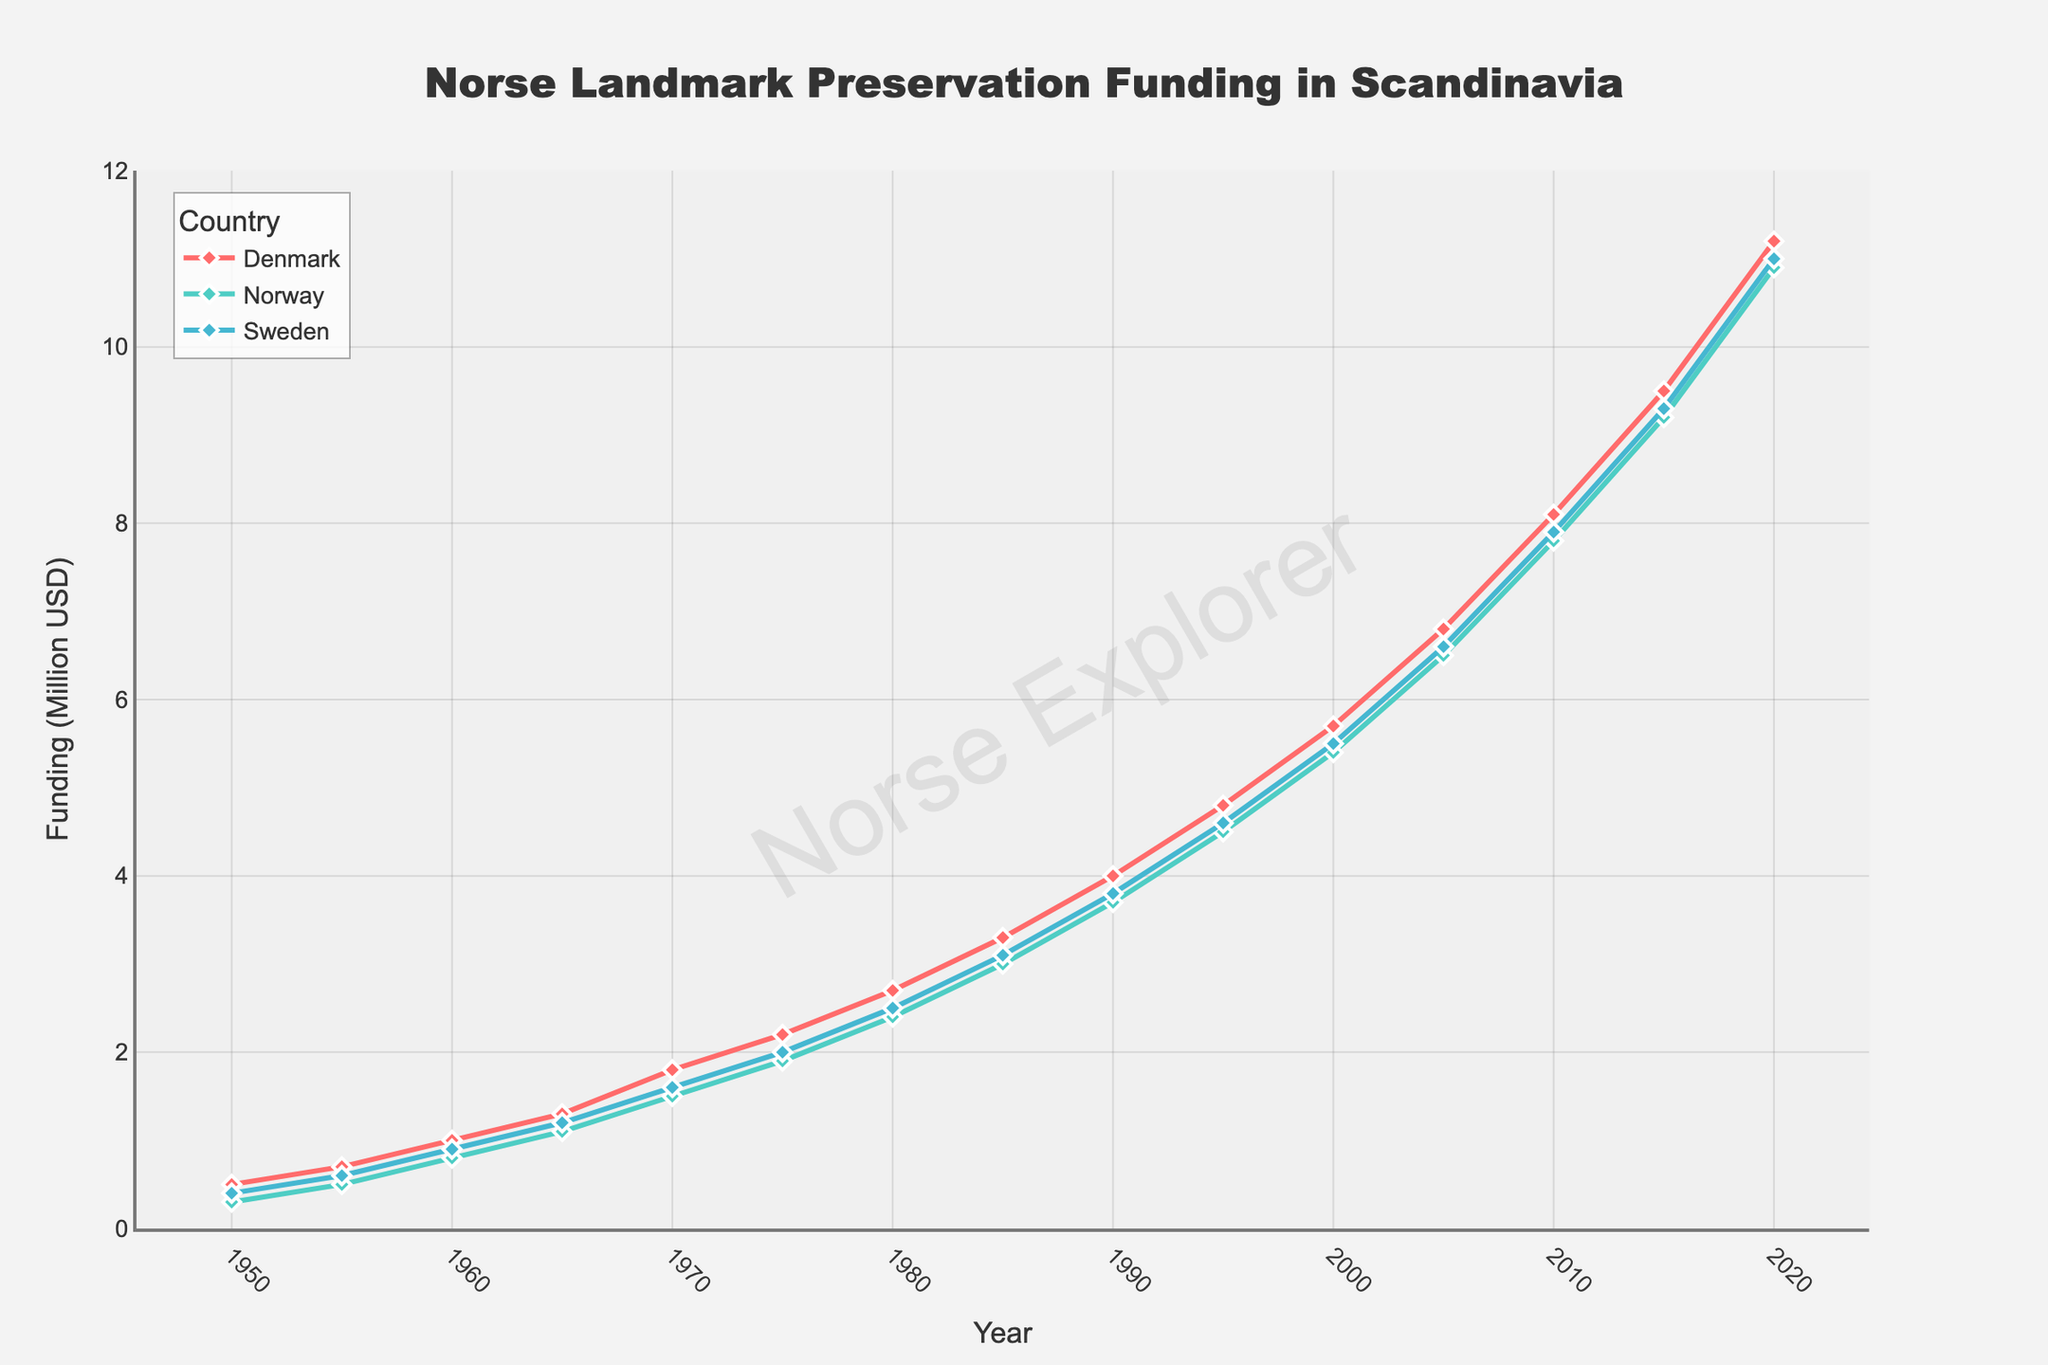What year did Norway's preservation funding first surpass 1 million USD? Look at the plot for Norway's funding curve crossing the 1 million USD mark. This occurs between 1960 and 1965. Checking the y-axis, it is at 1965.
Answer: 1965 By how much did preservation funding increase in Denmark from 1950 to 2020? For Denmark, the funding in 1950 was 0.5 million USD, and in 2020 it was 11.2 million USD. Subtract the earlier value from the later value: 11.2 - 0.5 = 10.7
Answer: 10.7 million USD Which country had the highest preservation funding in 1980? Observe the data points for 1980 on the plot and compare the heights for Denmark, Norway, and Sweden. Denmark is the highest with 2.7 million USD.
Answer: Denmark What is the average increase in funding per decade for Sweden from 1950 to 2020? Calculate the total increase from 1950 to 2020, which is 11.0 - 0.4 = 10.6 million USD. There are 7 decades in this period, so the average increase is 10.6 / 7 ≈ 1.51 million USD.
Answer: 1.51 million USD In which year did Norway's funding curve equal Sweden's funding curve for the second time? The funding for Norway and Sweden matches again at 2015 after their first match in 1955. Both had funding of 9.3 million USD in 2015.
Answer: 2015 What is the total preservation funding combined for all three countries in the year 2000? Add the funding for Denmark, Norway, and Sweden in 2000: 5.7 + 5.4 + 5.5 = 16.6 million USD.
Answer: 16.6 million USD Which country showed the most consistent growth in preservation funding over the period displayed? Visually analyze the smoothness and linearity of growth curves for each country. Denmark shows the most consistent, steady increase without significant deviations.
Answer: Denmark 